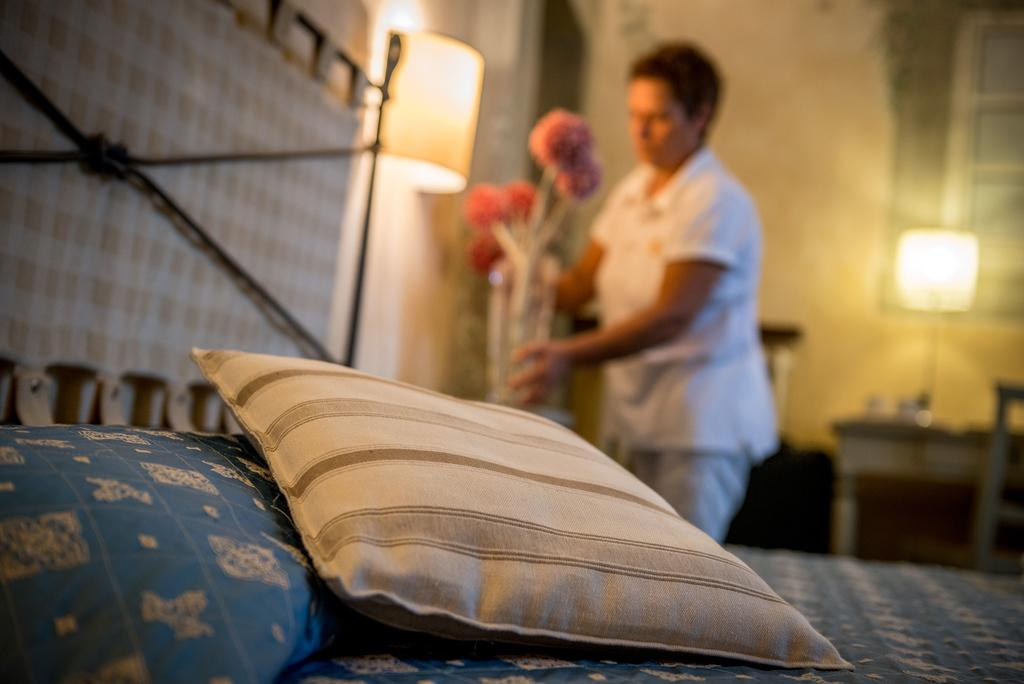What is on the bed in the image? There is a pillow on the bed in the image. Can you describe the background of the image? There is a blurred image of a person holding a flower vase in the background. What furniture is present in the image? There is a table and a chair in the image. What can be seen in terms of lighting in the image? There are lights visible in the image. What type of cough does the scarecrow have in the image? There is no scarecrow present in the image, and therefore no cough can be observed. What type of pipe is being used by the person in the image? There is no pipe visible in the image; the person is holding a flower vase. 